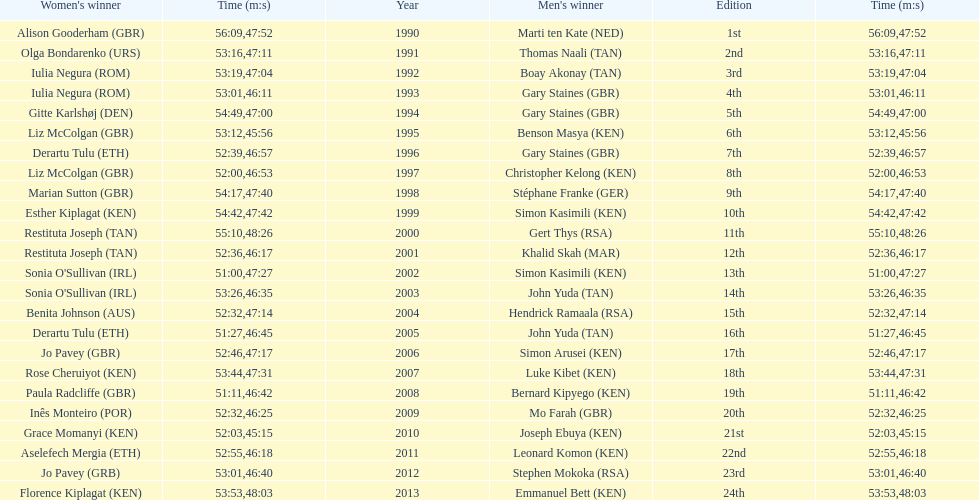What is the difference in finishing times for the men's and women's bupa great south run finish for 2013? 5:50. 